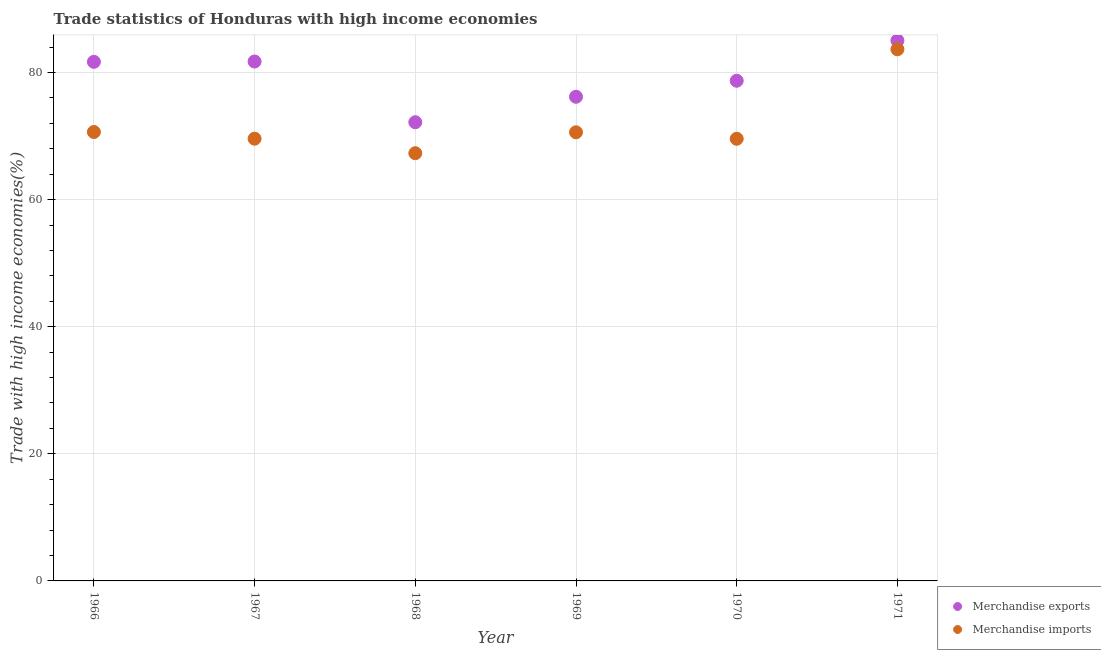What is the merchandise imports in 1969?
Give a very brief answer. 70.59. Across all years, what is the maximum merchandise exports?
Your response must be concise. 85.04. Across all years, what is the minimum merchandise imports?
Provide a short and direct response. 67.3. In which year was the merchandise imports maximum?
Offer a very short reply. 1971. In which year was the merchandise imports minimum?
Provide a short and direct response. 1968. What is the total merchandise imports in the graph?
Ensure brevity in your answer.  431.35. What is the difference between the merchandise imports in 1968 and that in 1971?
Ensure brevity in your answer.  -16.35. What is the difference between the merchandise imports in 1968 and the merchandise exports in 1967?
Provide a succinct answer. -14.43. What is the average merchandise imports per year?
Your response must be concise. 71.89. In the year 1967, what is the difference between the merchandise exports and merchandise imports?
Provide a short and direct response. 12.14. What is the ratio of the merchandise imports in 1970 to that in 1971?
Ensure brevity in your answer.  0.83. What is the difference between the highest and the second highest merchandise imports?
Ensure brevity in your answer.  13.02. What is the difference between the highest and the lowest merchandise exports?
Give a very brief answer. 12.86. In how many years, is the merchandise exports greater than the average merchandise exports taken over all years?
Offer a terse response. 3. Does the merchandise imports monotonically increase over the years?
Make the answer very short. No. Is the merchandise imports strictly less than the merchandise exports over the years?
Provide a short and direct response. Yes. What is the difference between two consecutive major ticks on the Y-axis?
Your response must be concise. 20. Where does the legend appear in the graph?
Offer a terse response. Bottom right. What is the title of the graph?
Your response must be concise. Trade statistics of Honduras with high income economies. What is the label or title of the Y-axis?
Your answer should be compact. Trade with high income economies(%). What is the Trade with high income economies(%) of Merchandise exports in 1966?
Make the answer very short. 81.68. What is the Trade with high income economies(%) of Merchandise imports in 1966?
Your response must be concise. 70.64. What is the Trade with high income economies(%) of Merchandise exports in 1967?
Provide a short and direct response. 81.73. What is the Trade with high income economies(%) in Merchandise imports in 1967?
Ensure brevity in your answer.  69.59. What is the Trade with high income economies(%) in Merchandise exports in 1968?
Provide a succinct answer. 72.18. What is the Trade with high income economies(%) in Merchandise imports in 1968?
Ensure brevity in your answer.  67.3. What is the Trade with high income economies(%) of Merchandise exports in 1969?
Make the answer very short. 76.18. What is the Trade with high income economies(%) of Merchandise imports in 1969?
Offer a very short reply. 70.59. What is the Trade with high income economies(%) in Merchandise exports in 1970?
Your answer should be very brief. 78.71. What is the Trade with high income economies(%) in Merchandise imports in 1970?
Offer a very short reply. 69.57. What is the Trade with high income economies(%) in Merchandise exports in 1971?
Your response must be concise. 85.04. What is the Trade with high income economies(%) of Merchandise imports in 1971?
Ensure brevity in your answer.  83.66. Across all years, what is the maximum Trade with high income economies(%) in Merchandise exports?
Your response must be concise. 85.04. Across all years, what is the maximum Trade with high income economies(%) of Merchandise imports?
Provide a short and direct response. 83.66. Across all years, what is the minimum Trade with high income economies(%) in Merchandise exports?
Provide a succinct answer. 72.18. Across all years, what is the minimum Trade with high income economies(%) of Merchandise imports?
Provide a short and direct response. 67.3. What is the total Trade with high income economies(%) of Merchandise exports in the graph?
Offer a terse response. 475.52. What is the total Trade with high income economies(%) in Merchandise imports in the graph?
Make the answer very short. 431.35. What is the difference between the Trade with high income economies(%) of Merchandise exports in 1966 and that in 1967?
Your answer should be very brief. -0.05. What is the difference between the Trade with high income economies(%) of Merchandise imports in 1966 and that in 1967?
Your answer should be compact. 1.05. What is the difference between the Trade with high income economies(%) in Merchandise exports in 1966 and that in 1968?
Give a very brief answer. 9.5. What is the difference between the Trade with high income economies(%) in Merchandise imports in 1966 and that in 1968?
Your response must be concise. 3.33. What is the difference between the Trade with high income economies(%) of Merchandise exports in 1966 and that in 1969?
Ensure brevity in your answer.  5.5. What is the difference between the Trade with high income economies(%) of Merchandise imports in 1966 and that in 1969?
Give a very brief answer. 0.05. What is the difference between the Trade with high income economies(%) of Merchandise exports in 1966 and that in 1970?
Make the answer very short. 2.98. What is the difference between the Trade with high income economies(%) of Merchandise imports in 1966 and that in 1970?
Give a very brief answer. 1.07. What is the difference between the Trade with high income economies(%) of Merchandise exports in 1966 and that in 1971?
Keep it short and to the point. -3.36. What is the difference between the Trade with high income economies(%) of Merchandise imports in 1966 and that in 1971?
Ensure brevity in your answer.  -13.02. What is the difference between the Trade with high income economies(%) of Merchandise exports in 1967 and that in 1968?
Keep it short and to the point. 9.55. What is the difference between the Trade with high income economies(%) in Merchandise imports in 1967 and that in 1968?
Provide a short and direct response. 2.28. What is the difference between the Trade with high income economies(%) of Merchandise exports in 1967 and that in 1969?
Keep it short and to the point. 5.55. What is the difference between the Trade with high income economies(%) of Merchandise imports in 1967 and that in 1969?
Provide a succinct answer. -1. What is the difference between the Trade with high income economies(%) in Merchandise exports in 1967 and that in 1970?
Offer a very short reply. 3.02. What is the difference between the Trade with high income economies(%) in Merchandise imports in 1967 and that in 1970?
Provide a short and direct response. 0.02. What is the difference between the Trade with high income economies(%) of Merchandise exports in 1967 and that in 1971?
Offer a terse response. -3.31. What is the difference between the Trade with high income economies(%) in Merchandise imports in 1967 and that in 1971?
Make the answer very short. -14.07. What is the difference between the Trade with high income economies(%) of Merchandise exports in 1968 and that in 1969?
Provide a short and direct response. -4.01. What is the difference between the Trade with high income economies(%) in Merchandise imports in 1968 and that in 1969?
Your answer should be compact. -3.29. What is the difference between the Trade with high income economies(%) in Merchandise exports in 1968 and that in 1970?
Keep it short and to the point. -6.53. What is the difference between the Trade with high income economies(%) in Merchandise imports in 1968 and that in 1970?
Ensure brevity in your answer.  -2.27. What is the difference between the Trade with high income economies(%) in Merchandise exports in 1968 and that in 1971?
Your response must be concise. -12.86. What is the difference between the Trade with high income economies(%) in Merchandise imports in 1968 and that in 1971?
Provide a succinct answer. -16.35. What is the difference between the Trade with high income economies(%) of Merchandise exports in 1969 and that in 1970?
Your answer should be very brief. -2.52. What is the difference between the Trade with high income economies(%) in Merchandise imports in 1969 and that in 1970?
Provide a short and direct response. 1.02. What is the difference between the Trade with high income economies(%) in Merchandise exports in 1969 and that in 1971?
Provide a short and direct response. -8.85. What is the difference between the Trade with high income economies(%) in Merchandise imports in 1969 and that in 1971?
Ensure brevity in your answer.  -13.06. What is the difference between the Trade with high income economies(%) of Merchandise exports in 1970 and that in 1971?
Your answer should be compact. -6.33. What is the difference between the Trade with high income economies(%) of Merchandise imports in 1970 and that in 1971?
Keep it short and to the point. -14.08. What is the difference between the Trade with high income economies(%) in Merchandise exports in 1966 and the Trade with high income economies(%) in Merchandise imports in 1967?
Your response must be concise. 12.09. What is the difference between the Trade with high income economies(%) of Merchandise exports in 1966 and the Trade with high income economies(%) of Merchandise imports in 1968?
Your answer should be compact. 14.38. What is the difference between the Trade with high income economies(%) in Merchandise exports in 1966 and the Trade with high income economies(%) in Merchandise imports in 1969?
Make the answer very short. 11.09. What is the difference between the Trade with high income economies(%) of Merchandise exports in 1966 and the Trade with high income economies(%) of Merchandise imports in 1970?
Your answer should be very brief. 12.11. What is the difference between the Trade with high income economies(%) of Merchandise exports in 1966 and the Trade with high income economies(%) of Merchandise imports in 1971?
Offer a very short reply. -1.97. What is the difference between the Trade with high income economies(%) in Merchandise exports in 1967 and the Trade with high income economies(%) in Merchandise imports in 1968?
Make the answer very short. 14.43. What is the difference between the Trade with high income economies(%) of Merchandise exports in 1967 and the Trade with high income economies(%) of Merchandise imports in 1969?
Provide a short and direct response. 11.14. What is the difference between the Trade with high income economies(%) in Merchandise exports in 1967 and the Trade with high income economies(%) in Merchandise imports in 1970?
Your answer should be very brief. 12.16. What is the difference between the Trade with high income economies(%) in Merchandise exports in 1967 and the Trade with high income economies(%) in Merchandise imports in 1971?
Provide a succinct answer. -1.93. What is the difference between the Trade with high income economies(%) of Merchandise exports in 1968 and the Trade with high income economies(%) of Merchandise imports in 1969?
Ensure brevity in your answer.  1.58. What is the difference between the Trade with high income economies(%) in Merchandise exports in 1968 and the Trade with high income economies(%) in Merchandise imports in 1970?
Offer a very short reply. 2.6. What is the difference between the Trade with high income economies(%) of Merchandise exports in 1968 and the Trade with high income economies(%) of Merchandise imports in 1971?
Offer a terse response. -11.48. What is the difference between the Trade with high income economies(%) in Merchandise exports in 1969 and the Trade with high income economies(%) in Merchandise imports in 1970?
Make the answer very short. 6.61. What is the difference between the Trade with high income economies(%) of Merchandise exports in 1969 and the Trade with high income economies(%) of Merchandise imports in 1971?
Offer a terse response. -7.47. What is the difference between the Trade with high income economies(%) in Merchandise exports in 1970 and the Trade with high income economies(%) in Merchandise imports in 1971?
Your answer should be very brief. -4.95. What is the average Trade with high income economies(%) in Merchandise exports per year?
Offer a terse response. 79.25. What is the average Trade with high income economies(%) in Merchandise imports per year?
Provide a short and direct response. 71.89. In the year 1966, what is the difference between the Trade with high income economies(%) of Merchandise exports and Trade with high income economies(%) of Merchandise imports?
Your response must be concise. 11.04. In the year 1967, what is the difference between the Trade with high income economies(%) in Merchandise exports and Trade with high income economies(%) in Merchandise imports?
Give a very brief answer. 12.14. In the year 1968, what is the difference between the Trade with high income economies(%) of Merchandise exports and Trade with high income economies(%) of Merchandise imports?
Your answer should be very brief. 4.87. In the year 1969, what is the difference between the Trade with high income economies(%) in Merchandise exports and Trade with high income economies(%) in Merchandise imports?
Keep it short and to the point. 5.59. In the year 1970, what is the difference between the Trade with high income economies(%) in Merchandise exports and Trade with high income economies(%) in Merchandise imports?
Your answer should be compact. 9.13. In the year 1971, what is the difference between the Trade with high income economies(%) in Merchandise exports and Trade with high income economies(%) in Merchandise imports?
Provide a succinct answer. 1.38. What is the ratio of the Trade with high income economies(%) of Merchandise exports in 1966 to that in 1967?
Offer a very short reply. 1. What is the ratio of the Trade with high income economies(%) in Merchandise imports in 1966 to that in 1967?
Offer a very short reply. 1.02. What is the ratio of the Trade with high income economies(%) in Merchandise exports in 1966 to that in 1968?
Ensure brevity in your answer.  1.13. What is the ratio of the Trade with high income economies(%) in Merchandise imports in 1966 to that in 1968?
Ensure brevity in your answer.  1.05. What is the ratio of the Trade with high income economies(%) in Merchandise exports in 1966 to that in 1969?
Ensure brevity in your answer.  1.07. What is the ratio of the Trade with high income economies(%) of Merchandise exports in 1966 to that in 1970?
Ensure brevity in your answer.  1.04. What is the ratio of the Trade with high income economies(%) in Merchandise imports in 1966 to that in 1970?
Provide a succinct answer. 1.02. What is the ratio of the Trade with high income economies(%) in Merchandise exports in 1966 to that in 1971?
Your answer should be very brief. 0.96. What is the ratio of the Trade with high income economies(%) in Merchandise imports in 1966 to that in 1971?
Ensure brevity in your answer.  0.84. What is the ratio of the Trade with high income economies(%) in Merchandise exports in 1967 to that in 1968?
Make the answer very short. 1.13. What is the ratio of the Trade with high income economies(%) of Merchandise imports in 1967 to that in 1968?
Your answer should be very brief. 1.03. What is the ratio of the Trade with high income economies(%) in Merchandise exports in 1967 to that in 1969?
Your answer should be very brief. 1.07. What is the ratio of the Trade with high income economies(%) of Merchandise imports in 1967 to that in 1969?
Ensure brevity in your answer.  0.99. What is the ratio of the Trade with high income economies(%) in Merchandise exports in 1967 to that in 1970?
Your answer should be very brief. 1.04. What is the ratio of the Trade with high income economies(%) of Merchandise imports in 1967 to that in 1970?
Make the answer very short. 1. What is the ratio of the Trade with high income economies(%) of Merchandise exports in 1967 to that in 1971?
Give a very brief answer. 0.96. What is the ratio of the Trade with high income economies(%) of Merchandise imports in 1967 to that in 1971?
Keep it short and to the point. 0.83. What is the ratio of the Trade with high income economies(%) of Merchandise imports in 1968 to that in 1969?
Keep it short and to the point. 0.95. What is the ratio of the Trade with high income economies(%) of Merchandise exports in 1968 to that in 1970?
Offer a terse response. 0.92. What is the ratio of the Trade with high income economies(%) of Merchandise imports in 1968 to that in 1970?
Offer a terse response. 0.97. What is the ratio of the Trade with high income economies(%) in Merchandise exports in 1968 to that in 1971?
Give a very brief answer. 0.85. What is the ratio of the Trade with high income economies(%) in Merchandise imports in 1968 to that in 1971?
Your answer should be very brief. 0.8. What is the ratio of the Trade with high income economies(%) in Merchandise exports in 1969 to that in 1970?
Provide a short and direct response. 0.97. What is the ratio of the Trade with high income economies(%) of Merchandise imports in 1969 to that in 1970?
Your answer should be compact. 1.01. What is the ratio of the Trade with high income economies(%) of Merchandise exports in 1969 to that in 1971?
Provide a succinct answer. 0.9. What is the ratio of the Trade with high income economies(%) in Merchandise imports in 1969 to that in 1971?
Give a very brief answer. 0.84. What is the ratio of the Trade with high income economies(%) of Merchandise exports in 1970 to that in 1971?
Offer a terse response. 0.93. What is the ratio of the Trade with high income economies(%) of Merchandise imports in 1970 to that in 1971?
Your answer should be compact. 0.83. What is the difference between the highest and the second highest Trade with high income economies(%) in Merchandise exports?
Offer a very short reply. 3.31. What is the difference between the highest and the second highest Trade with high income economies(%) of Merchandise imports?
Provide a short and direct response. 13.02. What is the difference between the highest and the lowest Trade with high income economies(%) of Merchandise exports?
Give a very brief answer. 12.86. What is the difference between the highest and the lowest Trade with high income economies(%) in Merchandise imports?
Offer a very short reply. 16.35. 